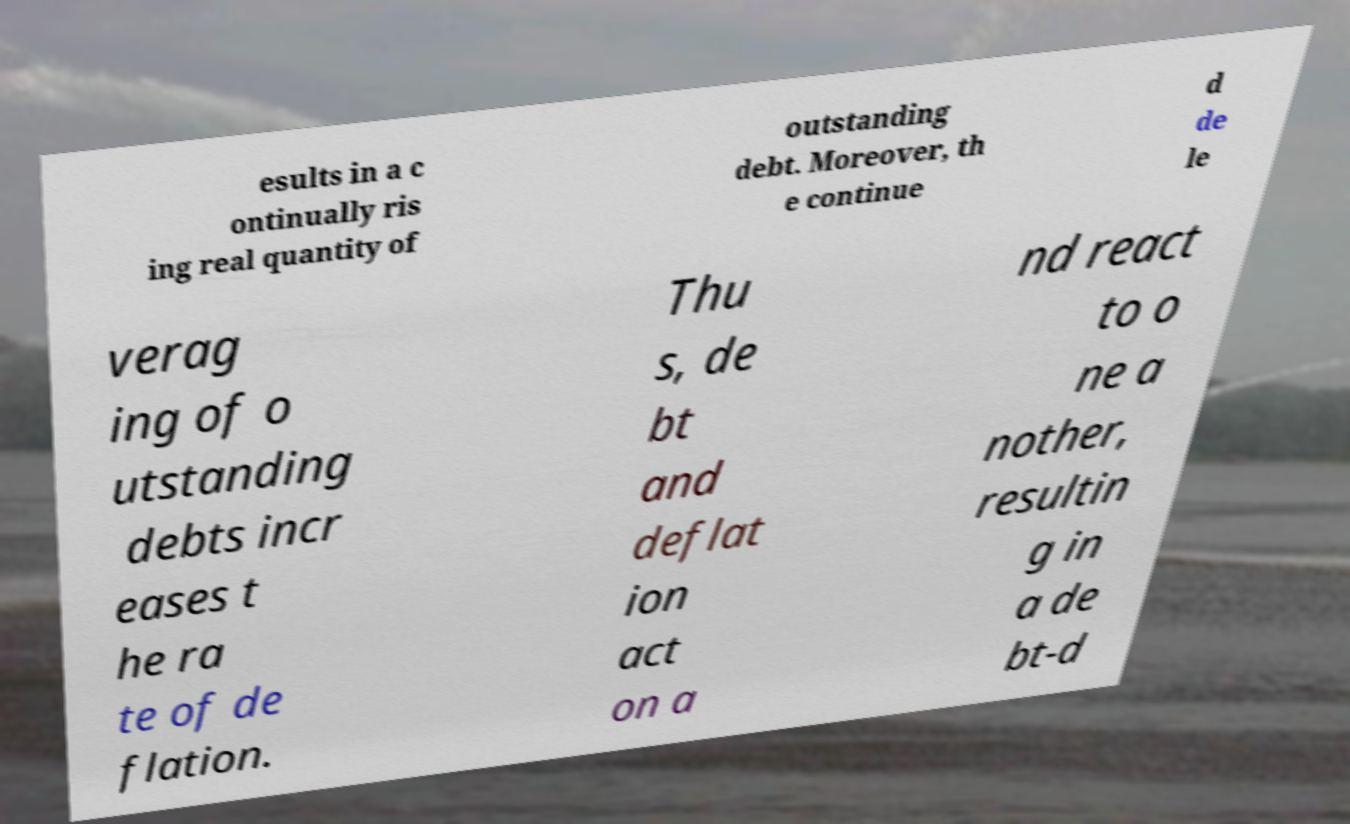For documentation purposes, I need the text within this image transcribed. Could you provide that? esults in a c ontinually ris ing real quantity of outstanding debt. Moreover, th e continue d de le verag ing of o utstanding debts incr eases t he ra te of de flation. Thu s, de bt and deflat ion act on a nd react to o ne a nother, resultin g in a de bt-d 